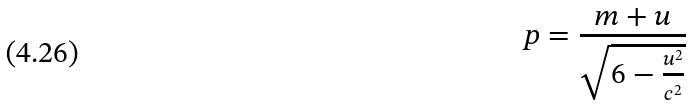Convert formula to latex. <formula><loc_0><loc_0><loc_500><loc_500>p = \frac { m + u } { \sqrt { 6 - \frac { u ^ { 2 } } { c ^ { 2 } } } }</formula> 